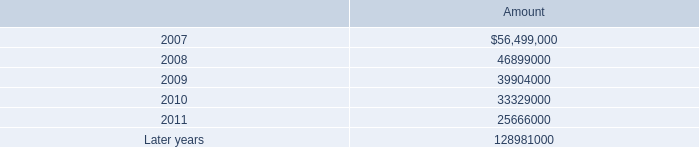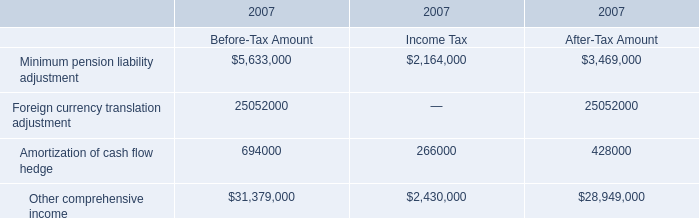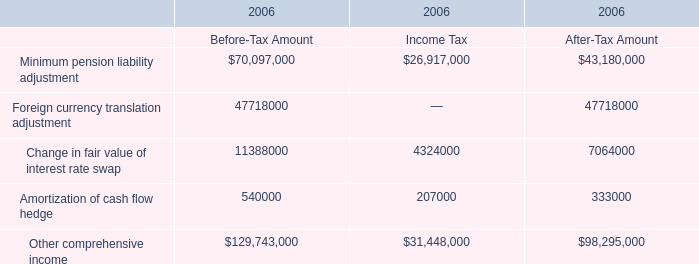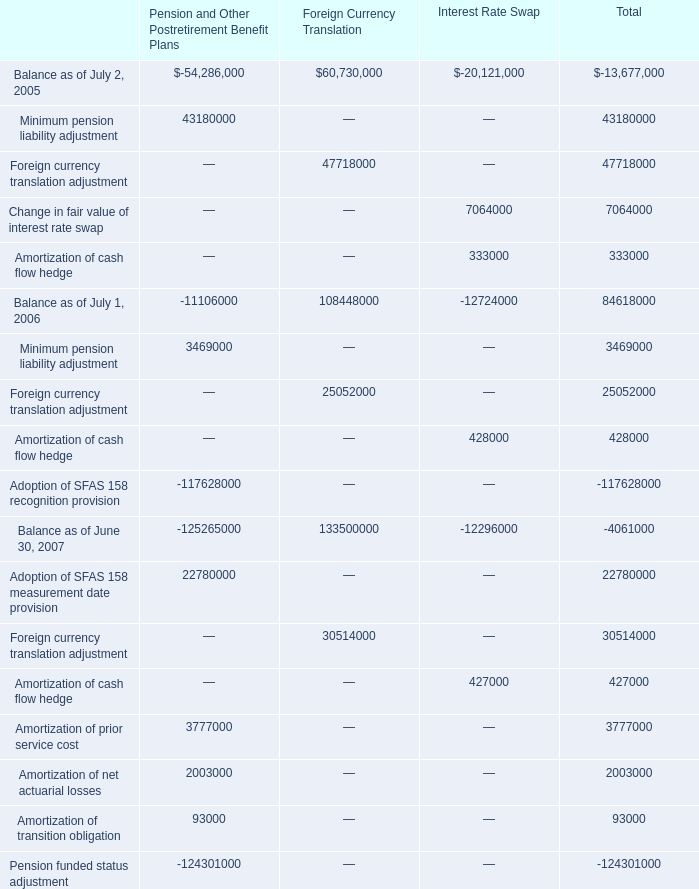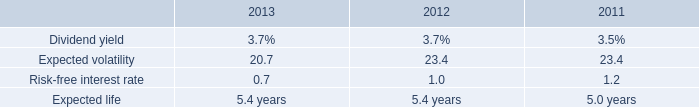What is the total amount of Foreign currency translation adjustment of Foreign Currency Translation, and Other comprehensive income of 2007 Income Tax ? 
Computations: (47718000.0 + 2430000.0)
Answer: 50148000.0. 